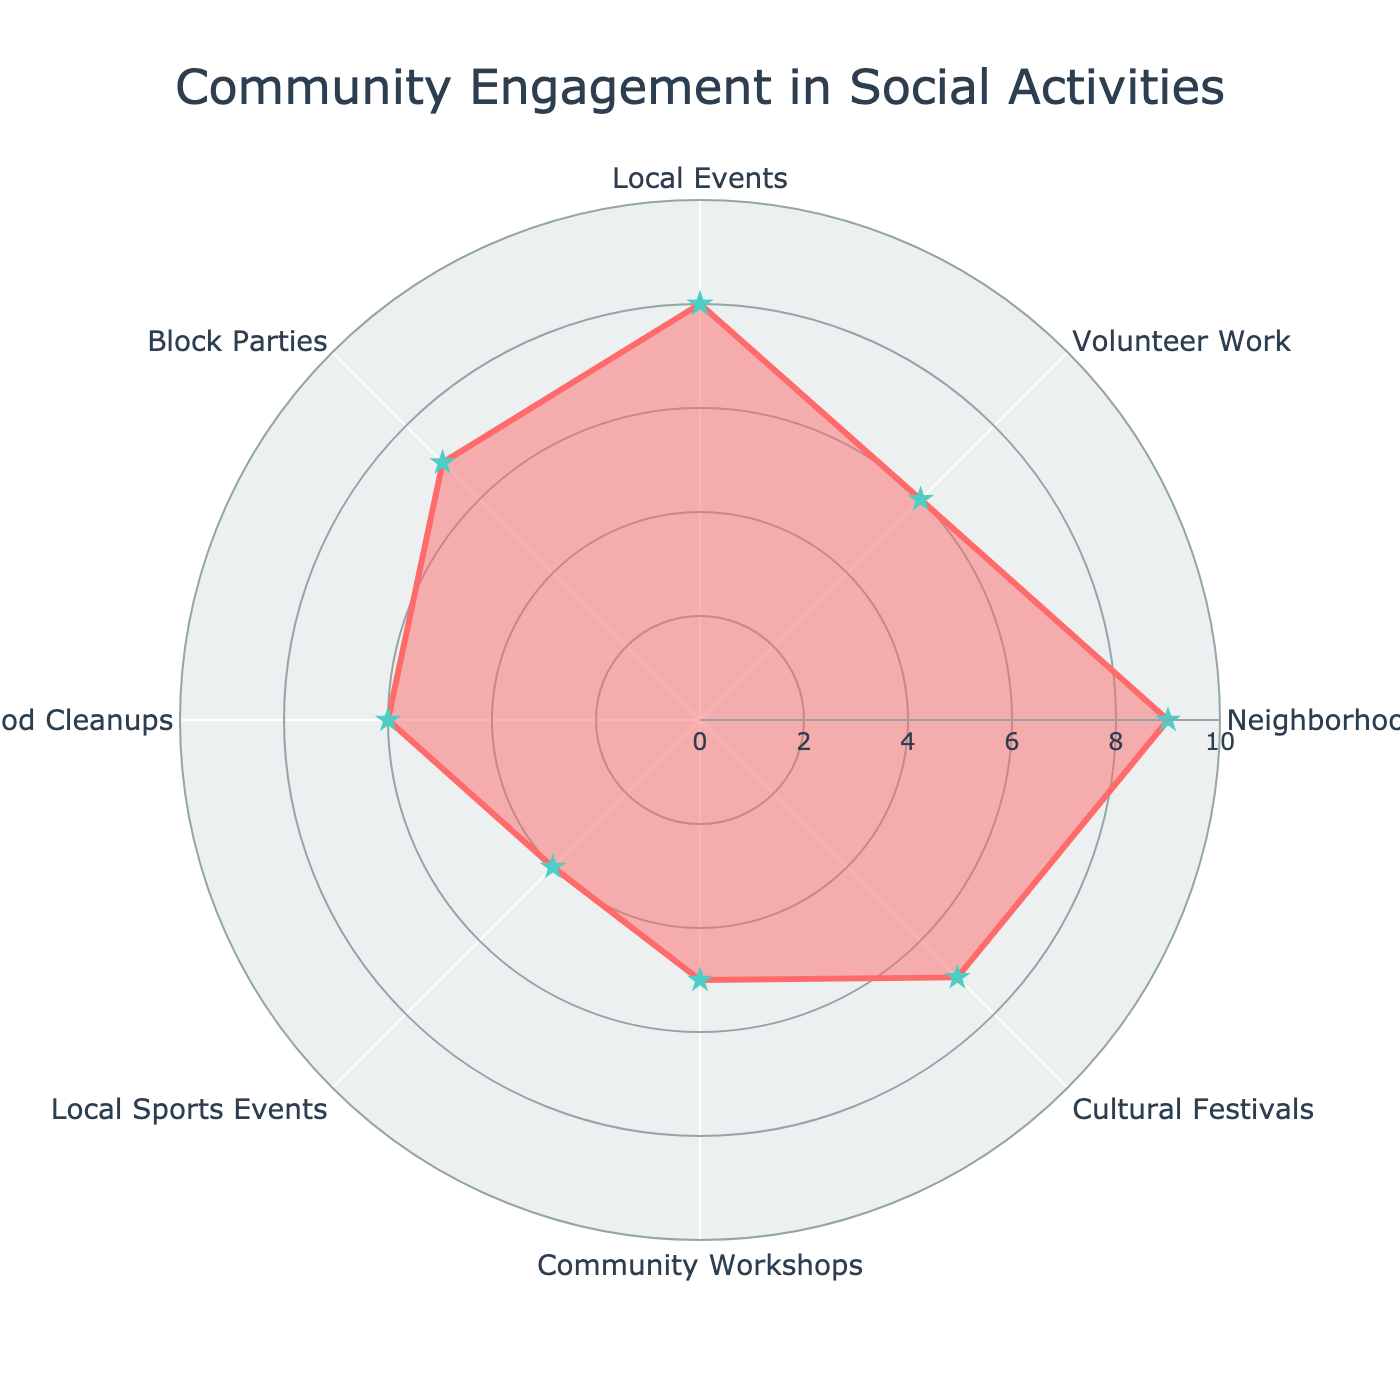What's the title of the figure? The title of the figure is written at the top center and it reads: "Community Engagement in Social Activities"
Answer: Community Engagement in Social Activities What category shows the highest frequency of participation? Looking at the radar chart, we can see that the category with the highest value on the scale is "Neighborhood Gatherings" with a value of 9.
Answer: Neighborhood Gatherings How many categories have a frequency of 7 or higher? By examining the values at the vertices of the radar chart, the categories that have a frequency of 7 or higher are "Local Events" (8), "Neighborhood Gatherings" (9), "Cultural Festivals" (7), and "Block Parties" (7). That's a total of 4 categories.
Answer: 4 What is the frequency of participation for Community Workshops? By referring to the specific point on the radar chart labeled "Community Workshops", we see that it has a frequency of 5.
Answer: 5 Which activity has the second lowest frequency of participation? The activity with the lowest frequency is "Local Sports Events" with a value of 4. The second lowest frequency value is 5, which corresponds to "Community Workshops".
Answer: Community Workshops What is the average frequency of participation in all categories? To find the average, sum all the frequencies: 8 (Local Events) + 6 (Volunteer Work) + 9 (Neighborhood Gatherings) + 7 (Cultural Festivals) + 5 (Community Workshops) + 4 (Local Sports Events) + 6 (Neighborhood Cleanups) + 7 (Block Parties) = 52. Divide by the number of categories (8): 52/8 = 6.5.
Answer: 6.5 Are there more categories with a frequency above 5 or below 5? To answer this, count the frequencies above 5: Local Events (8), Volunteer Work (6), Neighborhood Gatherings (9), Cultural Festivals (7), Neighborhood Cleanups (6), Block Parties (7) = 6. Count the frequencies below 5: Local Sports Events (4), Community Workshops (5). Since 5 is not above or below, we have 6 above and 1 below.
Answer: Above Do any categories have the same frequency of participation? By visually inspecting the radar chart, we can see that "Volunteer Work" and "Neighborhood Cleanups" both have a frequency of 6, and "Cultural Festivals" and "Block Parties" both have a frequency of 7.
Answer: Yes What's the difference in the frequency of participation between the highest and lowest categories? The highest frequency is "Neighborhood Gatherings" with a value of 9 and the lowest is "Local Sports Events" with a value of 4. The difference is 9 - 4 = 5.
Answer: 5 